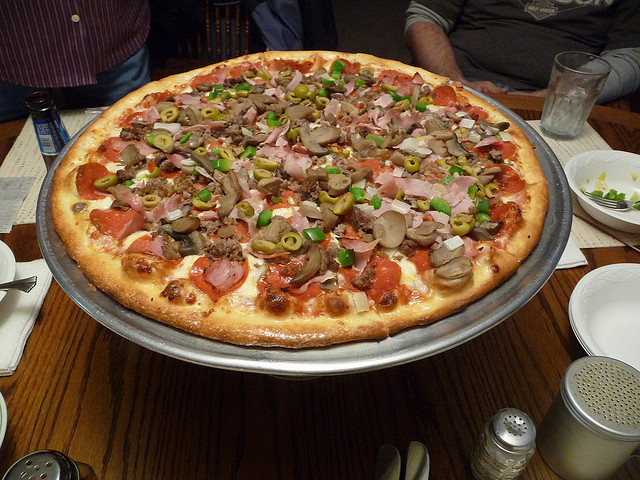What toppings can be seen on this pizza? The pizza is generously topped with a variety of ingredients including green olives, sliced tomatoes, onions, mushrooms, and pieces of ham and ground beef. 